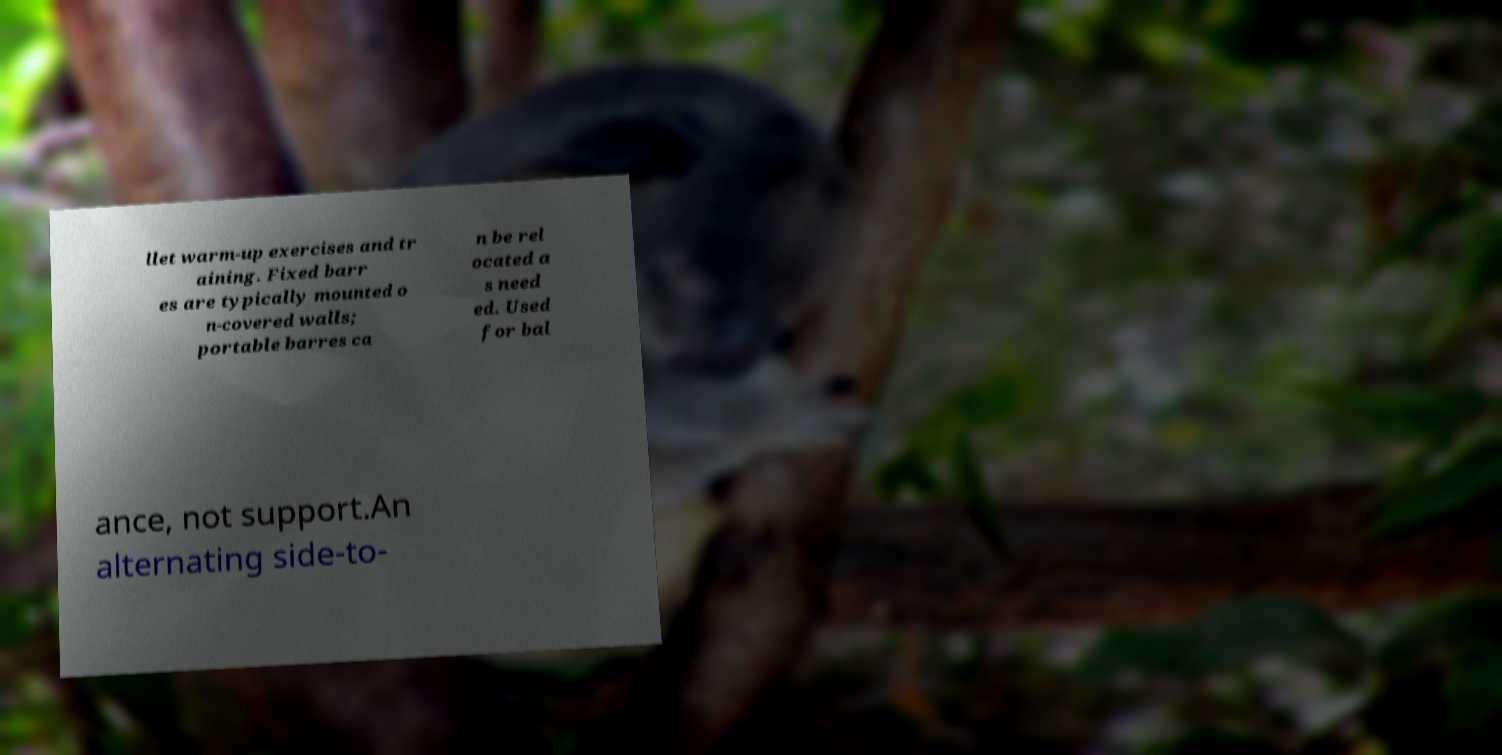For documentation purposes, I need the text within this image transcribed. Could you provide that? llet warm-up exercises and tr aining. Fixed barr es are typically mounted o n-covered walls; portable barres ca n be rel ocated a s need ed. Used for bal ance, not support.An alternating side-to- 